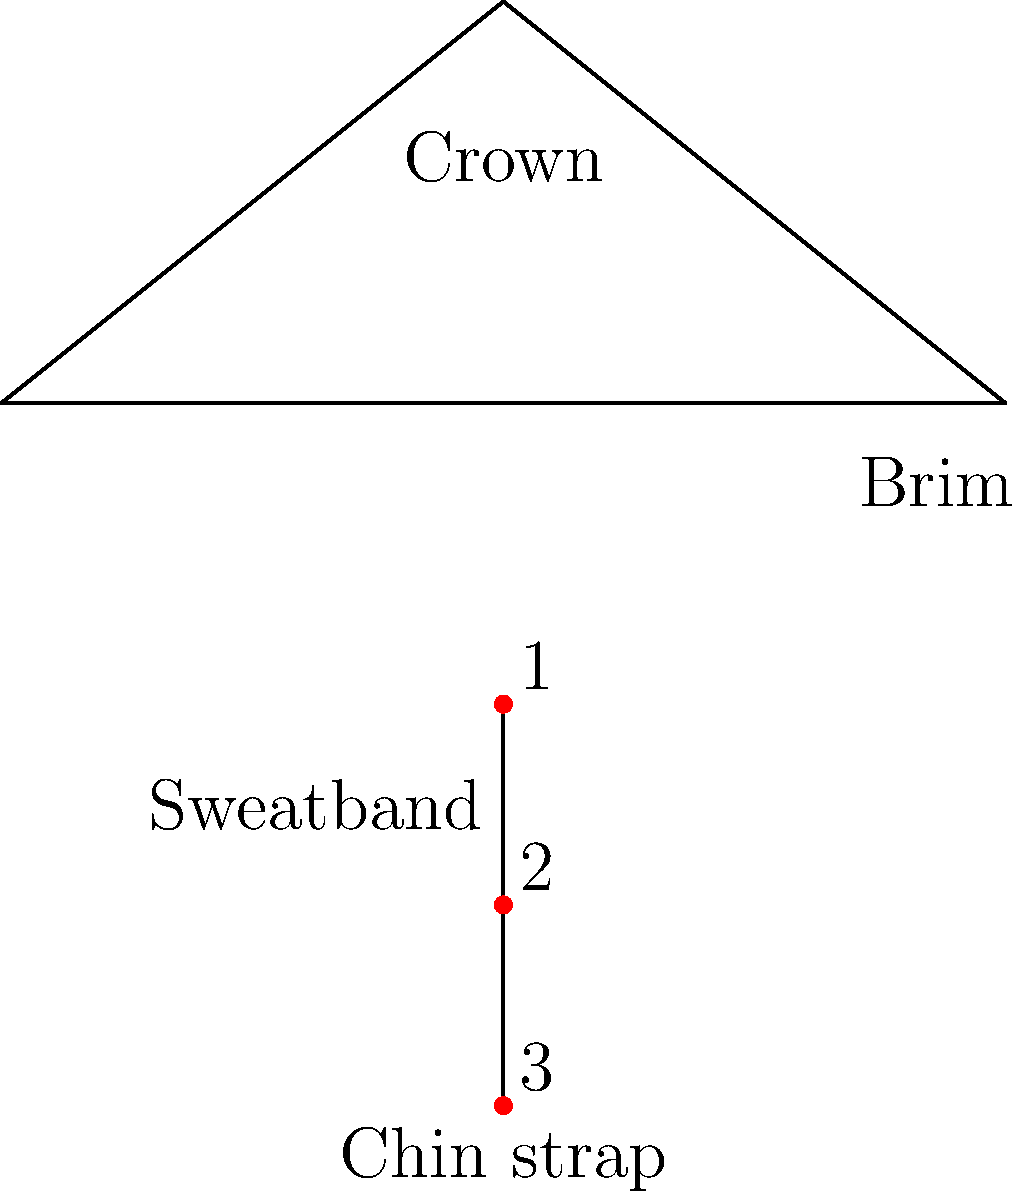In the diagram of a traditional Mexican sombrero, what do the red dots labeled 1, 2, and 3 represent? To answer this question, let's analyze the structure of the traditional Mexican sombrero as shown in the diagram:

1. The top part of the sombrero is the crown, which is the main body that covers the head.
2. The wide, circular brim extends outward from the base of the crown.
3. Inside the hat, there's typically a sweatband for comfort and fit.
4. At the bottom, we see the chin strap, which helps keep the sombrero secure on the head.

Now, looking at the red dots labeled 1, 2, and 3:

1. They are positioned vertically along the center axis of the sombrero.
2. They are located below the main body of the hat.
3. They appear to be connected by a line, which is labeled as the "chin strap."

Given this information, we can conclude that the red dots represent the adjustment points on the chin strap. These points allow the wearer to adjust the length and fit of the strap, ensuring the sombrero stays securely on the head even in windy conditions or during physical activity.
Answer: Adjustment points on the chin strap 